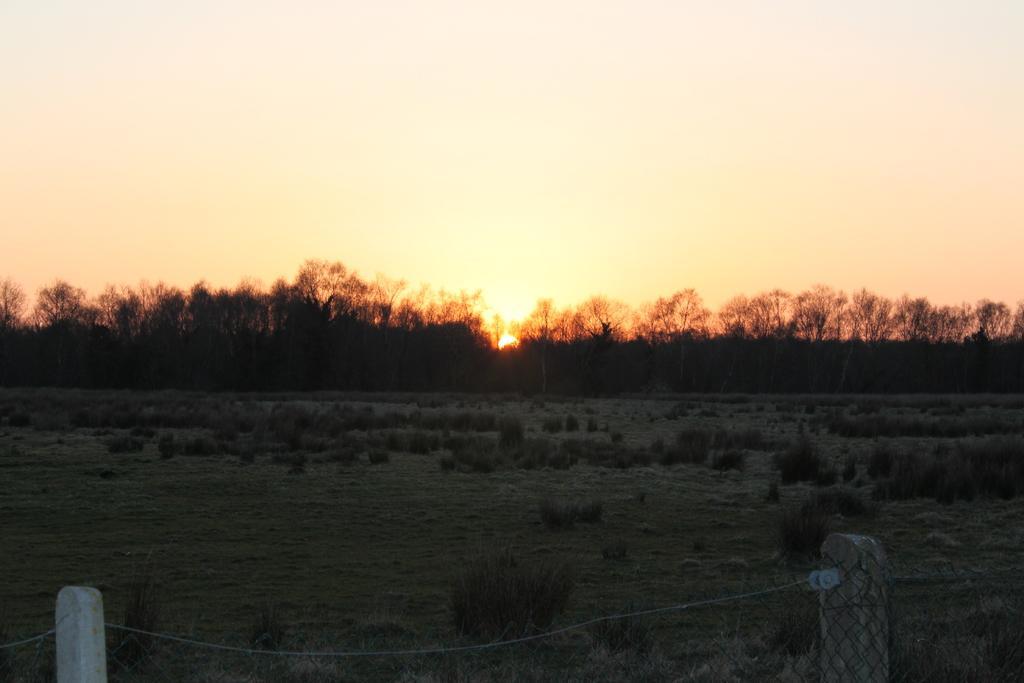Could you give a brief overview of what you see in this image? In this image, we can see poles and a rope. In the background, there are trees and plants. At the bottom, there is ground and at the top, there is sunset in the sky. 